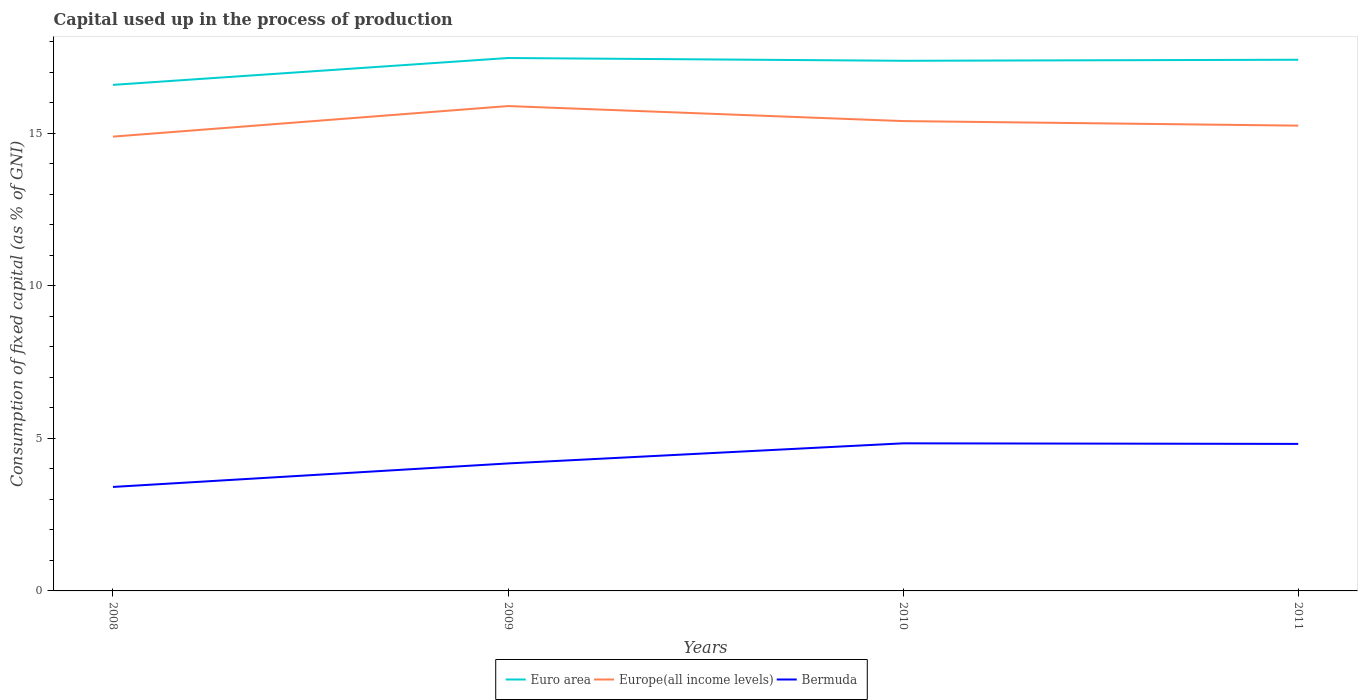How many different coloured lines are there?
Provide a succinct answer. 3. Is the number of lines equal to the number of legend labels?
Keep it short and to the point. Yes. Across all years, what is the maximum capital used up in the process of production in Euro area?
Ensure brevity in your answer.  16.59. In which year was the capital used up in the process of production in Europe(all income levels) maximum?
Your answer should be compact. 2008. What is the total capital used up in the process of production in Europe(all income levels) in the graph?
Keep it short and to the point. -0.51. What is the difference between the highest and the second highest capital used up in the process of production in Europe(all income levels)?
Ensure brevity in your answer.  1. Is the capital used up in the process of production in Europe(all income levels) strictly greater than the capital used up in the process of production in Bermuda over the years?
Give a very brief answer. No. How many years are there in the graph?
Your response must be concise. 4. Where does the legend appear in the graph?
Ensure brevity in your answer.  Bottom center. How many legend labels are there?
Offer a terse response. 3. How are the legend labels stacked?
Offer a terse response. Horizontal. What is the title of the graph?
Provide a short and direct response. Capital used up in the process of production. What is the label or title of the Y-axis?
Offer a terse response. Consumption of fixed capital (as % of GNI). What is the Consumption of fixed capital (as % of GNI) of Euro area in 2008?
Your answer should be compact. 16.59. What is the Consumption of fixed capital (as % of GNI) of Europe(all income levels) in 2008?
Provide a succinct answer. 14.89. What is the Consumption of fixed capital (as % of GNI) of Bermuda in 2008?
Provide a succinct answer. 3.41. What is the Consumption of fixed capital (as % of GNI) of Euro area in 2009?
Offer a very short reply. 17.47. What is the Consumption of fixed capital (as % of GNI) of Europe(all income levels) in 2009?
Your response must be concise. 15.89. What is the Consumption of fixed capital (as % of GNI) of Bermuda in 2009?
Your response must be concise. 4.18. What is the Consumption of fixed capital (as % of GNI) in Euro area in 2010?
Your answer should be compact. 17.38. What is the Consumption of fixed capital (as % of GNI) in Europe(all income levels) in 2010?
Provide a short and direct response. 15.4. What is the Consumption of fixed capital (as % of GNI) of Bermuda in 2010?
Provide a succinct answer. 4.84. What is the Consumption of fixed capital (as % of GNI) of Euro area in 2011?
Provide a succinct answer. 17.41. What is the Consumption of fixed capital (as % of GNI) of Europe(all income levels) in 2011?
Your answer should be compact. 15.25. What is the Consumption of fixed capital (as % of GNI) in Bermuda in 2011?
Provide a short and direct response. 4.82. Across all years, what is the maximum Consumption of fixed capital (as % of GNI) in Euro area?
Give a very brief answer. 17.47. Across all years, what is the maximum Consumption of fixed capital (as % of GNI) in Europe(all income levels)?
Your answer should be very brief. 15.89. Across all years, what is the maximum Consumption of fixed capital (as % of GNI) in Bermuda?
Provide a succinct answer. 4.84. Across all years, what is the minimum Consumption of fixed capital (as % of GNI) in Euro area?
Give a very brief answer. 16.59. Across all years, what is the minimum Consumption of fixed capital (as % of GNI) of Europe(all income levels)?
Give a very brief answer. 14.89. Across all years, what is the minimum Consumption of fixed capital (as % of GNI) in Bermuda?
Your response must be concise. 3.41. What is the total Consumption of fixed capital (as % of GNI) in Euro area in the graph?
Give a very brief answer. 68.84. What is the total Consumption of fixed capital (as % of GNI) of Europe(all income levels) in the graph?
Ensure brevity in your answer.  61.43. What is the total Consumption of fixed capital (as % of GNI) in Bermuda in the graph?
Offer a very short reply. 17.24. What is the difference between the Consumption of fixed capital (as % of GNI) in Euro area in 2008 and that in 2009?
Your answer should be compact. -0.88. What is the difference between the Consumption of fixed capital (as % of GNI) in Europe(all income levels) in 2008 and that in 2009?
Your answer should be very brief. -1. What is the difference between the Consumption of fixed capital (as % of GNI) of Bermuda in 2008 and that in 2009?
Offer a terse response. -0.77. What is the difference between the Consumption of fixed capital (as % of GNI) in Euro area in 2008 and that in 2010?
Offer a terse response. -0.79. What is the difference between the Consumption of fixed capital (as % of GNI) in Europe(all income levels) in 2008 and that in 2010?
Keep it short and to the point. -0.51. What is the difference between the Consumption of fixed capital (as % of GNI) of Bermuda in 2008 and that in 2010?
Provide a short and direct response. -1.43. What is the difference between the Consumption of fixed capital (as % of GNI) of Euro area in 2008 and that in 2011?
Make the answer very short. -0.82. What is the difference between the Consumption of fixed capital (as % of GNI) in Europe(all income levels) in 2008 and that in 2011?
Your answer should be compact. -0.36. What is the difference between the Consumption of fixed capital (as % of GNI) in Bermuda in 2008 and that in 2011?
Provide a succinct answer. -1.41. What is the difference between the Consumption of fixed capital (as % of GNI) of Euro area in 2009 and that in 2010?
Offer a very short reply. 0.09. What is the difference between the Consumption of fixed capital (as % of GNI) of Europe(all income levels) in 2009 and that in 2010?
Provide a succinct answer. 0.49. What is the difference between the Consumption of fixed capital (as % of GNI) in Bermuda in 2009 and that in 2010?
Offer a terse response. -0.66. What is the difference between the Consumption of fixed capital (as % of GNI) in Euro area in 2009 and that in 2011?
Provide a succinct answer. 0.06. What is the difference between the Consumption of fixed capital (as % of GNI) of Europe(all income levels) in 2009 and that in 2011?
Provide a succinct answer. 0.64. What is the difference between the Consumption of fixed capital (as % of GNI) in Bermuda in 2009 and that in 2011?
Provide a succinct answer. -0.64. What is the difference between the Consumption of fixed capital (as % of GNI) of Euro area in 2010 and that in 2011?
Provide a short and direct response. -0.03. What is the difference between the Consumption of fixed capital (as % of GNI) in Europe(all income levels) in 2010 and that in 2011?
Provide a succinct answer. 0.15. What is the difference between the Consumption of fixed capital (as % of GNI) in Bermuda in 2010 and that in 2011?
Keep it short and to the point. 0.02. What is the difference between the Consumption of fixed capital (as % of GNI) of Euro area in 2008 and the Consumption of fixed capital (as % of GNI) of Europe(all income levels) in 2009?
Your answer should be very brief. 0.69. What is the difference between the Consumption of fixed capital (as % of GNI) of Euro area in 2008 and the Consumption of fixed capital (as % of GNI) of Bermuda in 2009?
Your answer should be compact. 12.41. What is the difference between the Consumption of fixed capital (as % of GNI) of Europe(all income levels) in 2008 and the Consumption of fixed capital (as % of GNI) of Bermuda in 2009?
Provide a short and direct response. 10.71. What is the difference between the Consumption of fixed capital (as % of GNI) of Euro area in 2008 and the Consumption of fixed capital (as % of GNI) of Europe(all income levels) in 2010?
Provide a short and direct response. 1.19. What is the difference between the Consumption of fixed capital (as % of GNI) of Euro area in 2008 and the Consumption of fixed capital (as % of GNI) of Bermuda in 2010?
Offer a very short reply. 11.75. What is the difference between the Consumption of fixed capital (as % of GNI) in Europe(all income levels) in 2008 and the Consumption of fixed capital (as % of GNI) in Bermuda in 2010?
Provide a succinct answer. 10.05. What is the difference between the Consumption of fixed capital (as % of GNI) of Euro area in 2008 and the Consumption of fixed capital (as % of GNI) of Europe(all income levels) in 2011?
Your answer should be very brief. 1.34. What is the difference between the Consumption of fixed capital (as % of GNI) of Euro area in 2008 and the Consumption of fixed capital (as % of GNI) of Bermuda in 2011?
Offer a terse response. 11.77. What is the difference between the Consumption of fixed capital (as % of GNI) in Europe(all income levels) in 2008 and the Consumption of fixed capital (as % of GNI) in Bermuda in 2011?
Offer a terse response. 10.07. What is the difference between the Consumption of fixed capital (as % of GNI) in Euro area in 2009 and the Consumption of fixed capital (as % of GNI) in Europe(all income levels) in 2010?
Keep it short and to the point. 2.07. What is the difference between the Consumption of fixed capital (as % of GNI) of Euro area in 2009 and the Consumption of fixed capital (as % of GNI) of Bermuda in 2010?
Provide a short and direct response. 12.63. What is the difference between the Consumption of fixed capital (as % of GNI) of Europe(all income levels) in 2009 and the Consumption of fixed capital (as % of GNI) of Bermuda in 2010?
Make the answer very short. 11.05. What is the difference between the Consumption of fixed capital (as % of GNI) in Euro area in 2009 and the Consumption of fixed capital (as % of GNI) in Europe(all income levels) in 2011?
Your answer should be very brief. 2.22. What is the difference between the Consumption of fixed capital (as % of GNI) of Euro area in 2009 and the Consumption of fixed capital (as % of GNI) of Bermuda in 2011?
Your response must be concise. 12.65. What is the difference between the Consumption of fixed capital (as % of GNI) in Europe(all income levels) in 2009 and the Consumption of fixed capital (as % of GNI) in Bermuda in 2011?
Make the answer very short. 11.07. What is the difference between the Consumption of fixed capital (as % of GNI) in Euro area in 2010 and the Consumption of fixed capital (as % of GNI) in Europe(all income levels) in 2011?
Your response must be concise. 2.13. What is the difference between the Consumption of fixed capital (as % of GNI) of Euro area in 2010 and the Consumption of fixed capital (as % of GNI) of Bermuda in 2011?
Provide a succinct answer. 12.56. What is the difference between the Consumption of fixed capital (as % of GNI) of Europe(all income levels) in 2010 and the Consumption of fixed capital (as % of GNI) of Bermuda in 2011?
Your answer should be compact. 10.58. What is the average Consumption of fixed capital (as % of GNI) in Euro area per year?
Your response must be concise. 17.21. What is the average Consumption of fixed capital (as % of GNI) of Europe(all income levels) per year?
Your answer should be compact. 15.36. What is the average Consumption of fixed capital (as % of GNI) in Bermuda per year?
Your answer should be compact. 4.31. In the year 2008, what is the difference between the Consumption of fixed capital (as % of GNI) in Euro area and Consumption of fixed capital (as % of GNI) in Europe(all income levels)?
Make the answer very short. 1.7. In the year 2008, what is the difference between the Consumption of fixed capital (as % of GNI) in Euro area and Consumption of fixed capital (as % of GNI) in Bermuda?
Ensure brevity in your answer.  13.18. In the year 2008, what is the difference between the Consumption of fixed capital (as % of GNI) in Europe(all income levels) and Consumption of fixed capital (as % of GNI) in Bermuda?
Keep it short and to the point. 11.48. In the year 2009, what is the difference between the Consumption of fixed capital (as % of GNI) of Euro area and Consumption of fixed capital (as % of GNI) of Europe(all income levels)?
Keep it short and to the point. 1.57. In the year 2009, what is the difference between the Consumption of fixed capital (as % of GNI) in Euro area and Consumption of fixed capital (as % of GNI) in Bermuda?
Make the answer very short. 13.29. In the year 2009, what is the difference between the Consumption of fixed capital (as % of GNI) in Europe(all income levels) and Consumption of fixed capital (as % of GNI) in Bermuda?
Your answer should be compact. 11.71. In the year 2010, what is the difference between the Consumption of fixed capital (as % of GNI) in Euro area and Consumption of fixed capital (as % of GNI) in Europe(all income levels)?
Offer a terse response. 1.98. In the year 2010, what is the difference between the Consumption of fixed capital (as % of GNI) of Euro area and Consumption of fixed capital (as % of GNI) of Bermuda?
Ensure brevity in your answer.  12.54. In the year 2010, what is the difference between the Consumption of fixed capital (as % of GNI) of Europe(all income levels) and Consumption of fixed capital (as % of GNI) of Bermuda?
Your response must be concise. 10.56. In the year 2011, what is the difference between the Consumption of fixed capital (as % of GNI) in Euro area and Consumption of fixed capital (as % of GNI) in Europe(all income levels)?
Ensure brevity in your answer.  2.16. In the year 2011, what is the difference between the Consumption of fixed capital (as % of GNI) in Euro area and Consumption of fixed capital (as % of GNI) in Bermuda?
Keep it short and to the point. 12.59. In the year 2011, what is the difference between the Consumption of fixed capital (as % of GNI) in Europe(all income levels) and Consumption of fixed capital (as % of GNI) in Bermuda?
Make the answer very short. 10.43. What is the ratio of the Consumption of fixed capital (as % of GNI) in Euro area in 2008 to that in 2009?
Your response must be concise. 0.95. What is the ratio of the Consumption of fixed capital (as % of GNI) in Europe(all income levels) in 2008 to that in 2009?
Provide a succinct answer. 0.94. What is the ratio of the Consumption of fixed capital (as % of GNI) of Bermuda in 2008 to that in 2009?
Offer a terse response. 0.82. What is the ratio of the Consumption of fixed capital (as % of GNI) of Euro area in 2008 to that in 2010?
Provide a succinct answer. 0.95. What is the ratio of the Consumption of fixed capital (as % of GNI) of Europe(all income levels) in 2008 to that in 2010?
Make the answer very short. 0.97. What is the ratio of the Consumption of fixed capital (as % of GNI) in Bermuda in 2008 to that in 2010?
Your response must be concise. 0.7. What is the ratio of the Consumption of fixed capital (as % of GNI) in Euro area in 2008 to that in 2011?
Give a very brief answer. 0.95. What is the ratio of the Consumption of fixed capital (as % of GNI) in Europe(all income levels) in 2008 to that in 2011?
Provide a succinct answer. 0.98. What is the ratio of the Consumption of fixed capital (as % of GNI) of Bermuda in 2008 to that in 2011?
Provide a short and direct response. 0.71. What is the ratio of the Consumption of fixed capital (as % of GNI) in Euro area in 2009 to that in 2010?
Give a very brief answer. 1.01. What is the ratio of the Consumption of fixed capital (as % of GNI) in Europe(all income levels) in 2009 to that in 2010?
Provide a short and direct response. 1.03. What is the ratio of the Consumption of fixed capital (as % of GNI) in Bermuda in 2009 to that in 2010?
Your answer should be very brief. 0.86. What is the ratio of the Consumption of fixed capital (as % of GNI) in Euro area in 2009 to that in 2011?
Offer a very short reply. 1. What is the ratio of the Consumption of fixed capital (as % of GNI) of Europe(all income levels) in 2009 to that in 2011?
Keep it short and to the point. 1.04. What is the ratio of the Consumption of fixed capital (as % of GNI) in Bermuda in 2009 to that in 2011?
Your response must be concise. 0.87. What is the ratio of the Consumption of fixed capital (as % of GNI) of Europe(all income levels) in 2010 to that in 2011?
Keep it short and to the point. 1.01. What is the ratio of the Consumption of fixed capital (as % of GNI) of Bermuda in 2010 to that in 2011?
Ensure brevity in your answer.  1. What is the difference between the highest and the second highest Consumption of fixed capital (as % of GNI) of Euro area?
Keep it short and to the point. 0.06. What is the difference between the highest and the second highest Consumption of fixed capital (as % of GNI) of Europe(all income levels)?
Ensure brevity in your answer.  0.49. What is the difference between the highest and the second highest Consumption of fixed capital (as % of GNI) of Bermuda?
Offer a terse response. 0.02. What is the difference between the highest and the lowest Consumption of fixed capital (as % of GNI) of Euro area?
Your answer should be compact. 0.88. What is the difference between the highest and the lowest Consumption of fixed capital (as % of GNI) of Bermuda?
Your response must be concise. 1.43. 